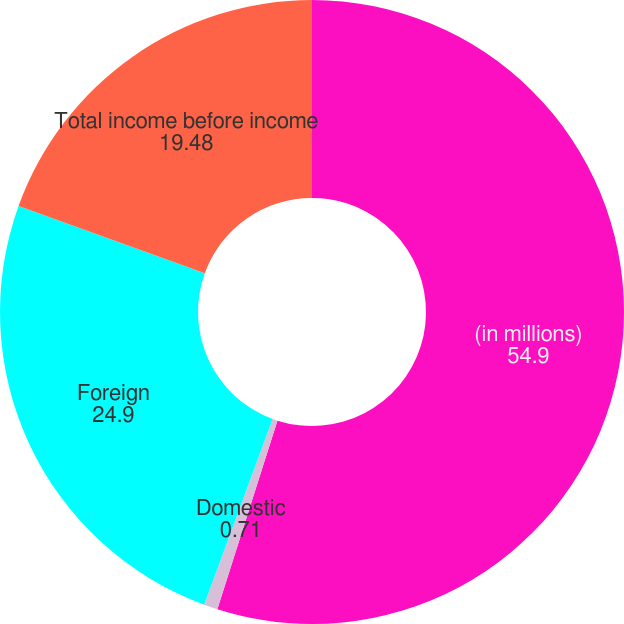Convert chart. <chart><loc_0><loc_0><loc_500><loc_500><pie_chart><fcel>(in millions)<fcel>Domestic<fcel>Foreign<fcel>Total income before income<nl><fcel>54.9%<fcel>0.71%<fcel>24.9%<fcel>19.48%<nl></chart> 